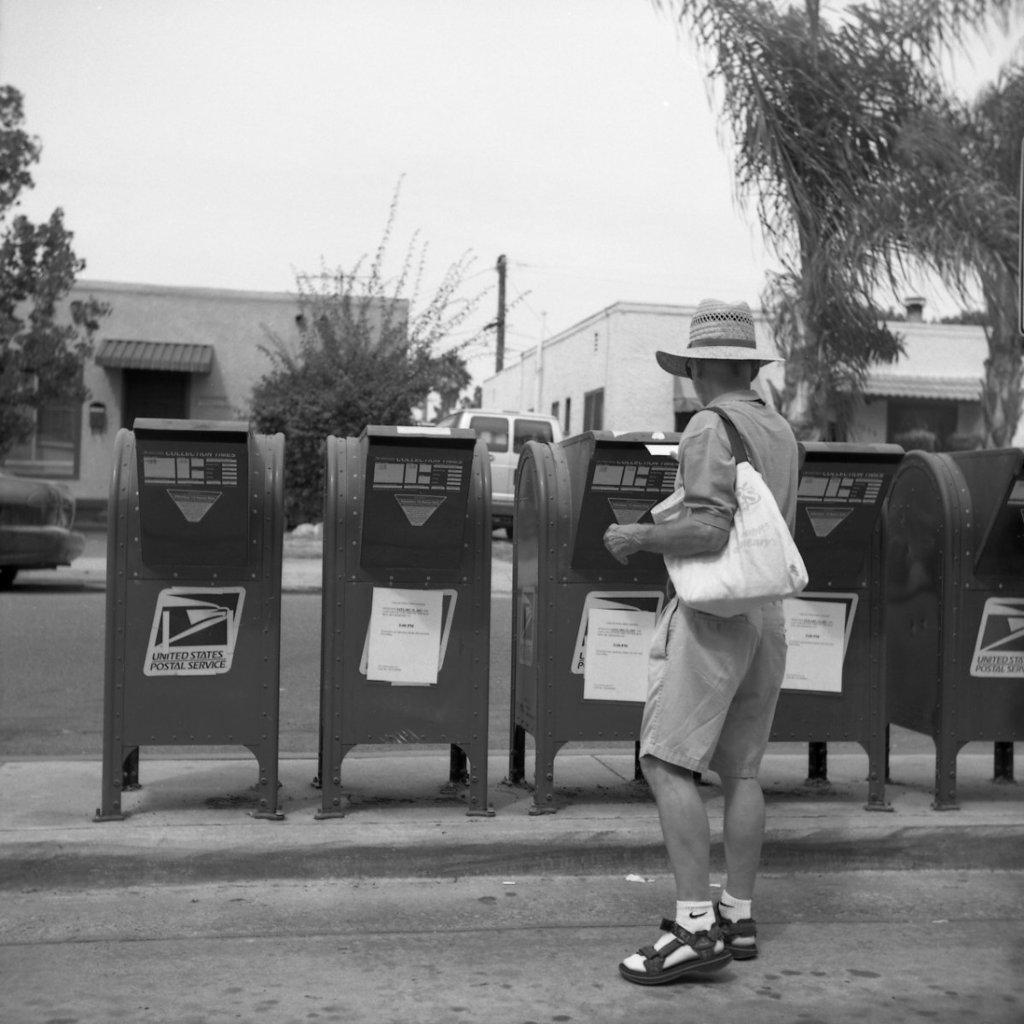<image>
Render a clear and concise summary of the photo. A man with a hat and sandals on drops off some mail for the United States Postal Service. 